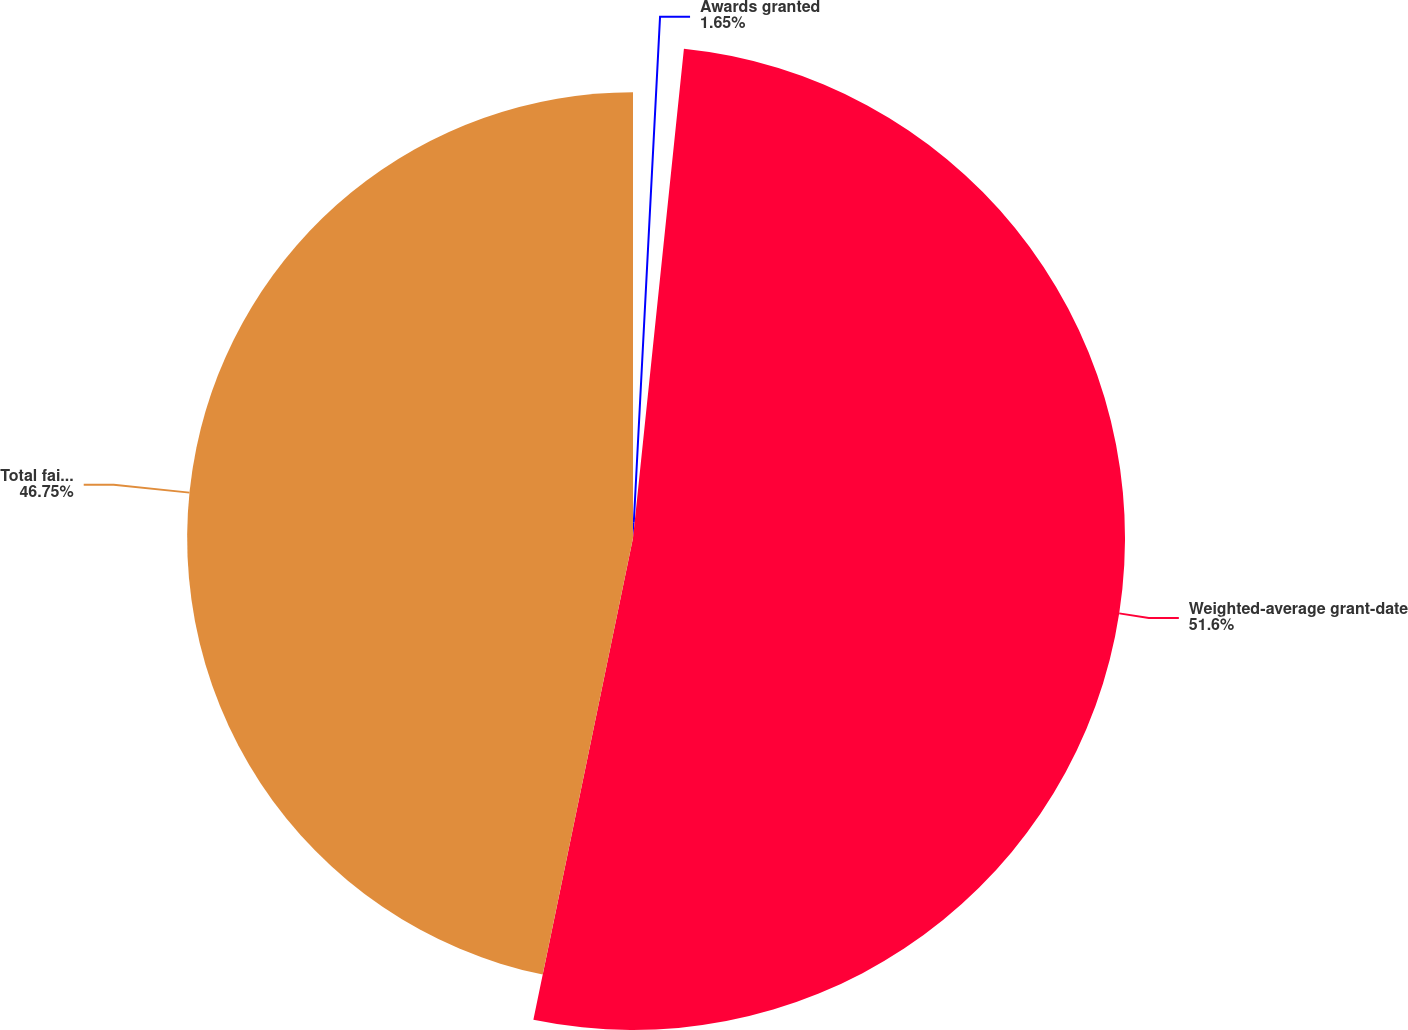Convert chart to OTSL. <chart><loc_0><loc_0><loc_500><loc_500><pie_chart><fcel>Awards granted<fcel>Weighted-average grant-date<fcel>Total fair value of vested<nl><fcel>1.65%<fcel>51.59%<fcel>46.75%<nl></chart> 